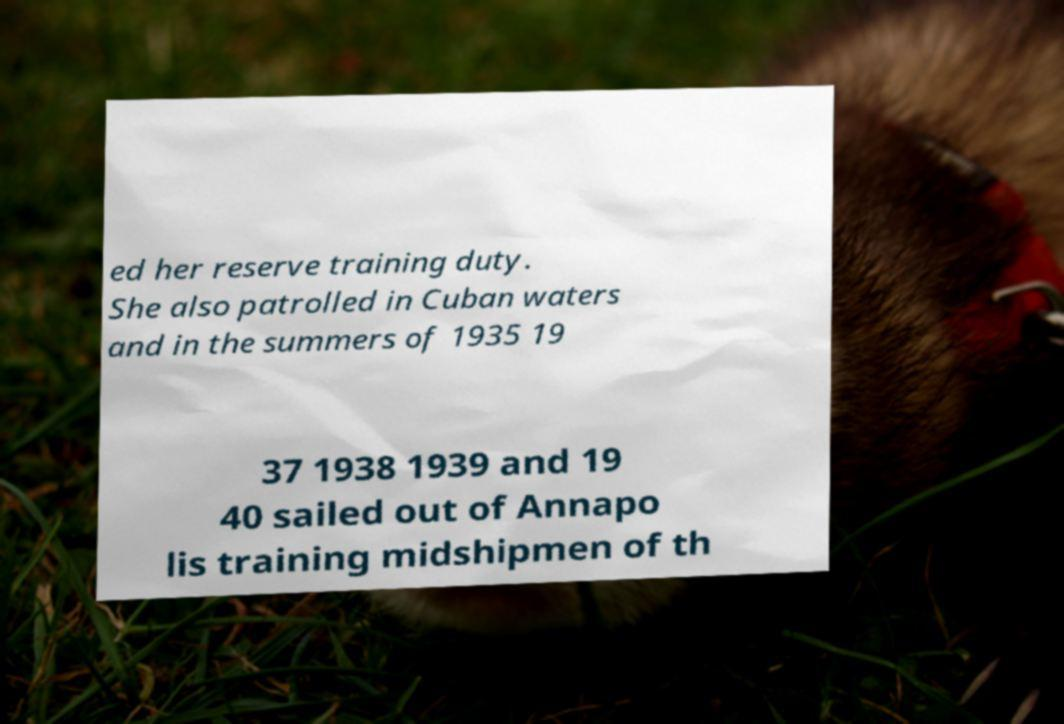Could you assist in decoding the text presented in this image and type it out clearly? ed her reserve training duty. She also patrolled in Cuban waters and in the summers of 1935 19 37 1938 1939 and 19 40 sailed out of Annapo lis training midshipmen of th 